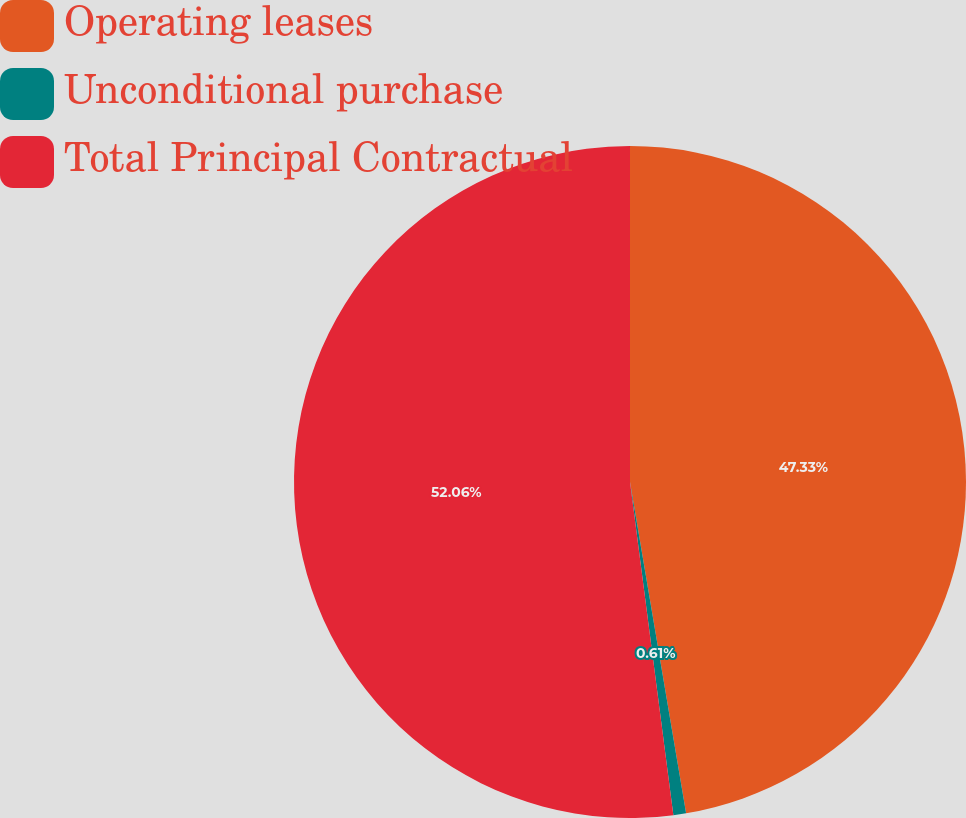Convert chart. <chart><loc_0><loc_0><loc_500><loc_500><pie_chart><fcel>Operating leases<fcel>Unconditional purchase<fcel>Total Principal Contractual<nl><fcel>47.33%<fcel>0.61%<fcel>52.06%<nl></chart> 